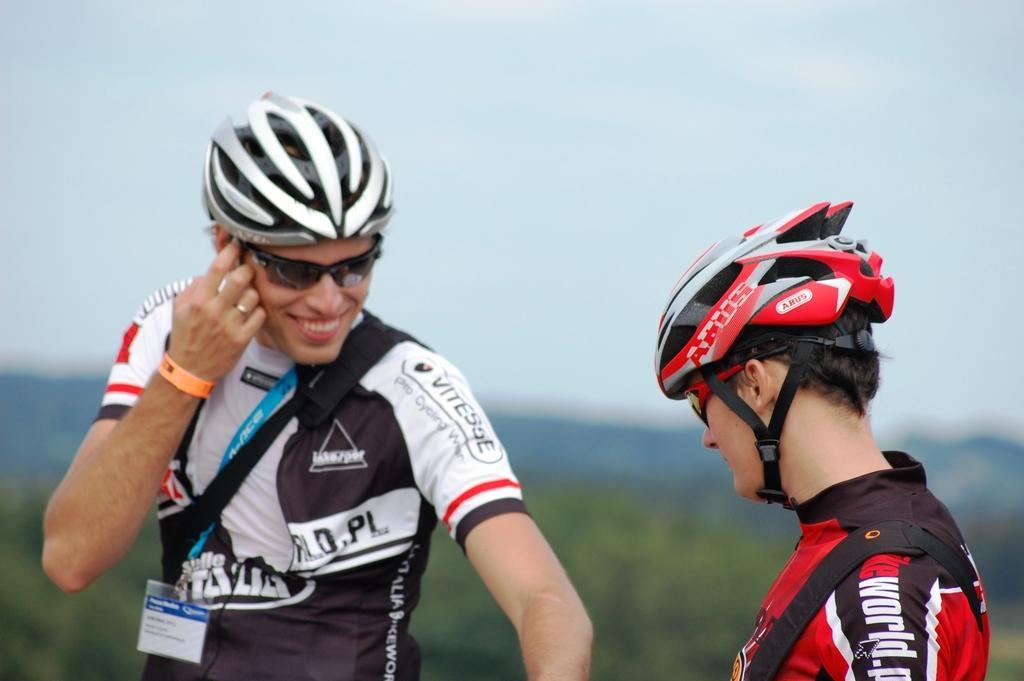How many people are present in the image? There are two persons in the image. Can you describe any specific clothing or accessories worn by one of the persons? One person is wearing an identity card. What can be seen in the background of the image? There is a sky visible in the image, and there are many trees as well. What type of wool is being spun by the person in the image? There is no wool or spinning activity present in the image. How many toes can be seen on the person's feet in the image? The image does not show the person's feet, so the number of toes cannot be determined. 